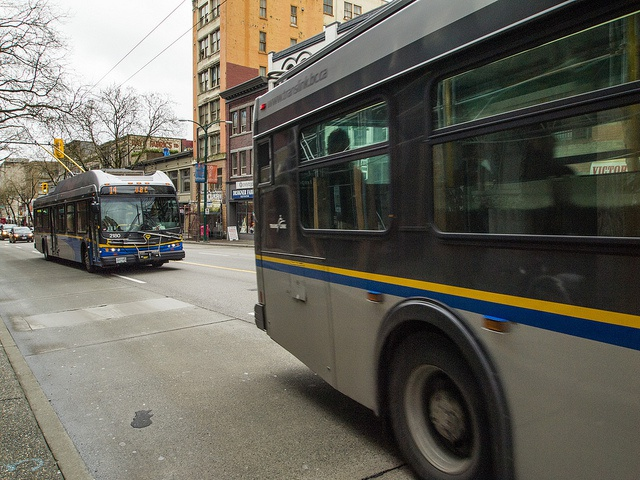Describe the objects in this image and their specific colors. I can see bus in lightgray, black, gray, and navy tones, bus in lightgray, black, gray, and darkgray tones, people in lightgray, black, and darkgreen tones, people in lightgray, black, and teal tones, and car in lightgray, black, darkgray, and gray tones in this image. 